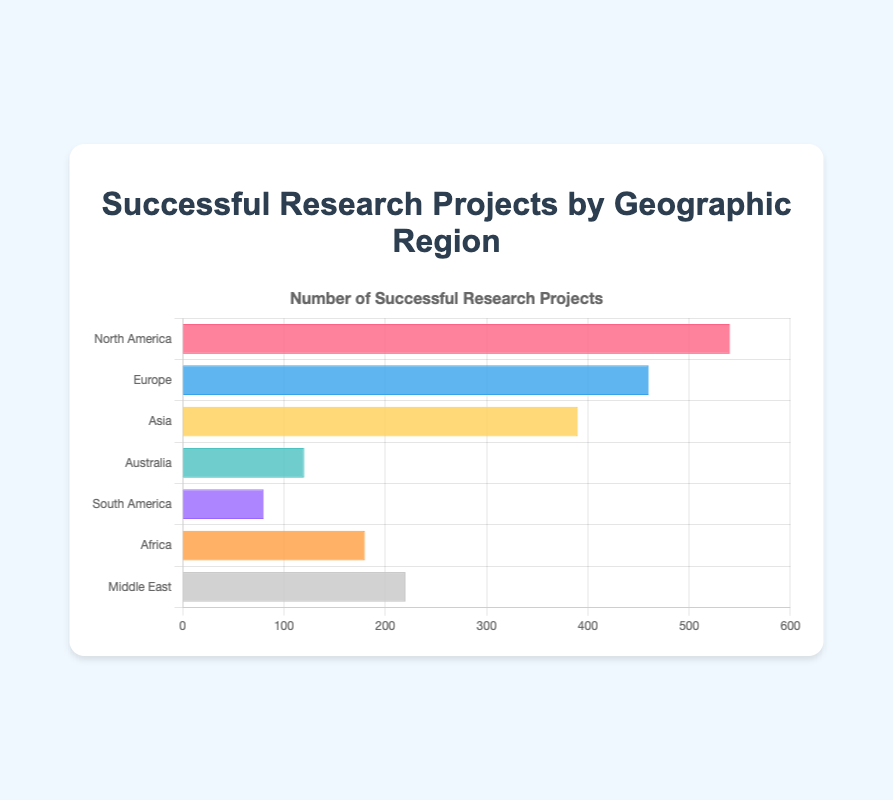Which region has the highest number of successful projects? By looking at the bars, the longest bar belongs to North America, indicating the highest number of successful projects.
Answer: North America How many more successful research projects does North America have than Asia? North America has 540 successful projects and Asia has 390. The difference is 540 - 390.
Answer: 150 Rank the geographic regions from highest to lowest based on the number of successful research projects. By comparing the lengths of the bars, the order is: North America, Europe, Asia, Middle East, Africa, Australia, South America.
Answer: North America, Europe, Asia, Middle East, Africa, Australia, South America Which region has the smallest number of successful research projects? The shortest bar represents South America, which has the smallest number of successful projects.
Answer: South America What is the total number of successful projects in Africa and the Middle East combined? The number of successful projects in Africa is 180 and in the Middle East is 220. The combined total is 180 + 220.
Answer: 400 Compare the successful projects in Europe and Middle East; which one has more and by how much? Europe has 460 successful projects, and the Middle East has 220. The difference is 460 - 220.
Answer: Europe, 240 more Which regions have bars colored in shades of blue? By examining the colors of the bars in the chart, Europe and Australia have shades of blue.
Answer: Europe, Australia What is the combined sum of successful research projects in the regions with the three highest values? The regions with the highest values are North America (540), Europe (460), and Asia (390). The combined sum is 540 + 460 + 390.
Answer: 1390 Calculate the average number of successful research projects across all regions. The sums of all successful projects are 540+460+390+120+80+180+220 = 1990. There are 7 regions, so the average is 1990 / 7.
Answer: 284.29 What percentage of the total successful research projects is contributed by Australia? Total projects are 1990, projects in Australia are 120. The percentage is (120 / 1990) * 100.
Answer: 6.03% 